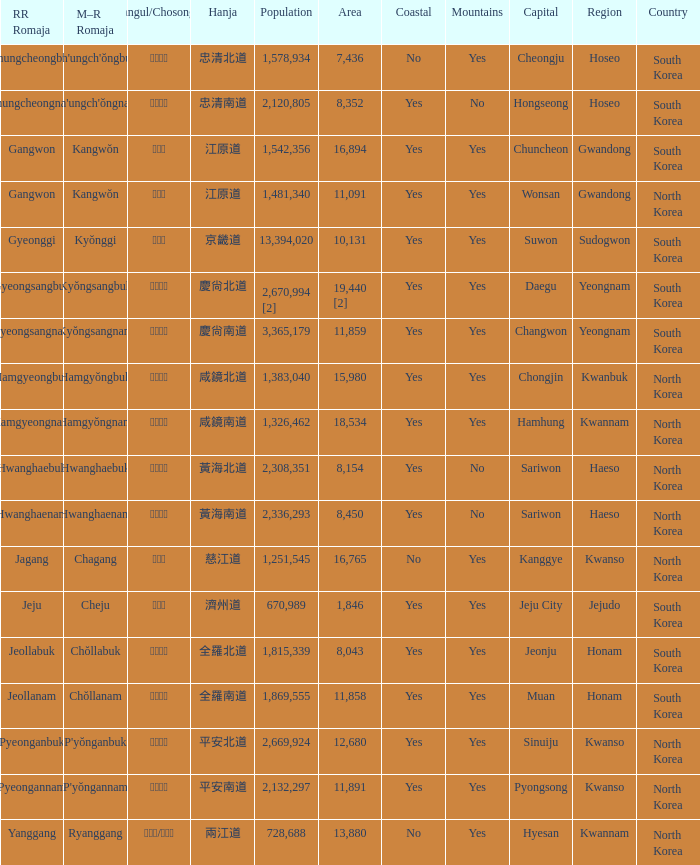Which capital has a Hangul of 경상남도? Changwon. 